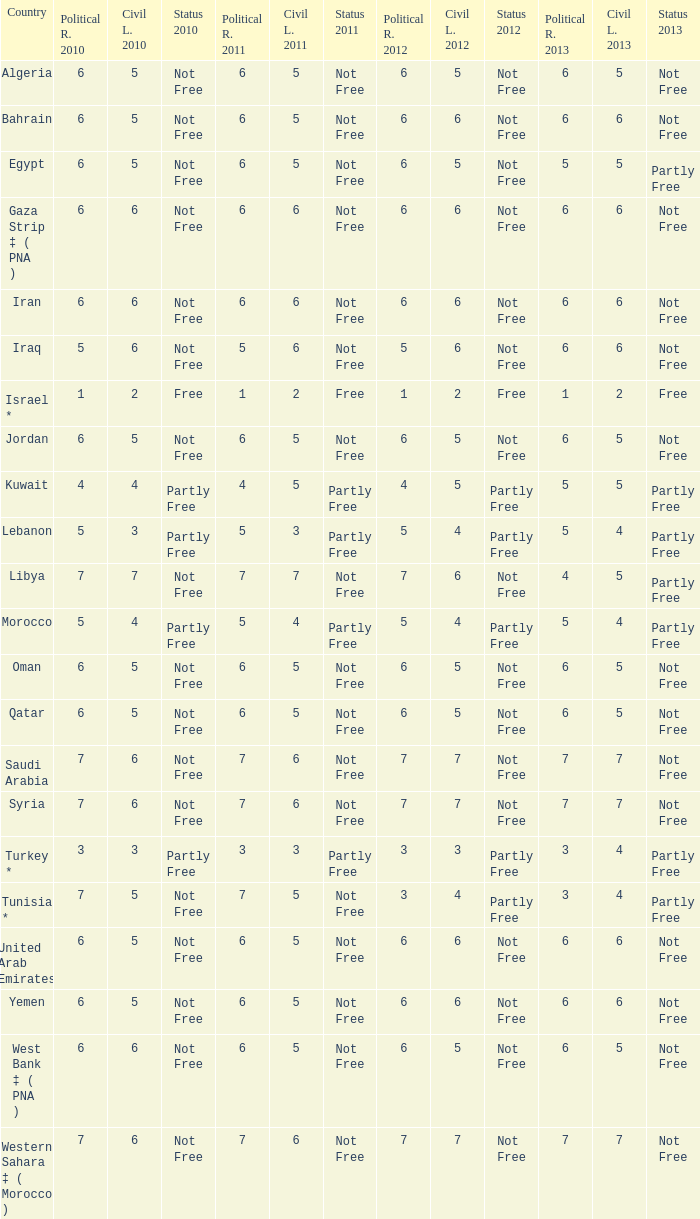What is the total number of civil liberties 2011 values having 2010 political rights values under 3 and 2011 political rights values under 1? 0.0. 